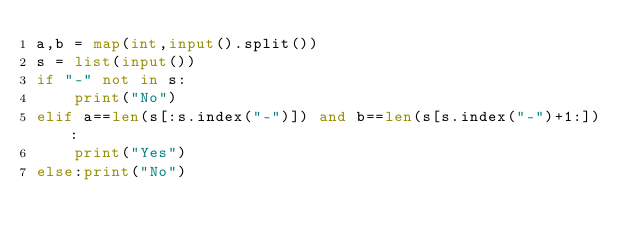<code> <loc_0><loc_0><loc_500><loc_500><_Python_>a,b = map(int,input().split())
s = list(input())
if "-" not in s:
    print("No")
elif a==len(s[:s.index("-")]) and b==len(s[s.index("-")+1:]):
    print("Yes")
else:print("No")</code> 